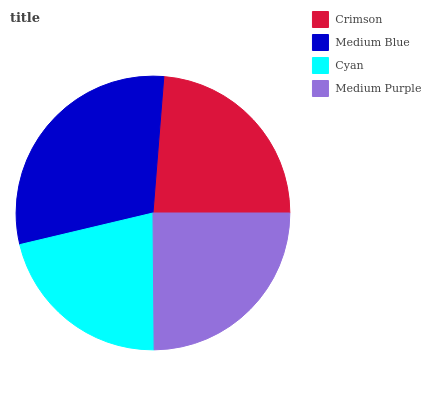Is Cyan the minimum?
Answer yes or no. Yes. Is Medium Blue the maximum?
Answer yes or no. Yes. Is Medium Blue the minimum?
Answer yes or no. No. Is Cyan the maximum?
Answer yes or no. No. Is Medium Blue greater than Cyan?
Answer yes or no. Yes. Is Cyan less than Medium Blue?
Answer yes or no. Yes. Is Cyan greater than Medium Blue?
Answer yes or no. No. Is Medium Blue less than Cyan?
Answer yes or no. No. Is Medium Purple the high median?
Answer yes or no. Yes. Is Crimson the low median?
Answer yes or no. Yes. Is Crimson the high median?
Answer yes or no. No. Is Cyan the low median?
Answer yes or no. No. 